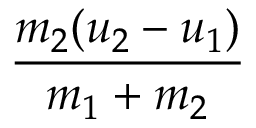<formula> <loc_0><loc_0><loc_500><loc_500>\frac { m _ { 2 } ( u _ { 2 } - u _ { 1 } ) } { m _ { 1 } + m _ { 2 } }</formula> 